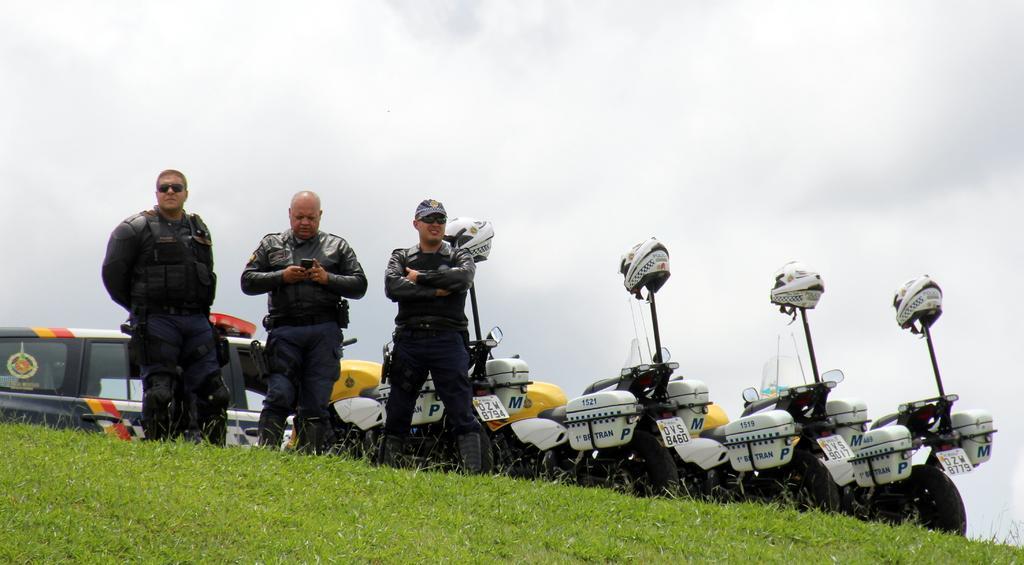Please provide a concise description of this image. In this picture we can see three men standing on the grass and at the back of them we can see vehicles, helmets and some objects and in the background we can see the sky. 